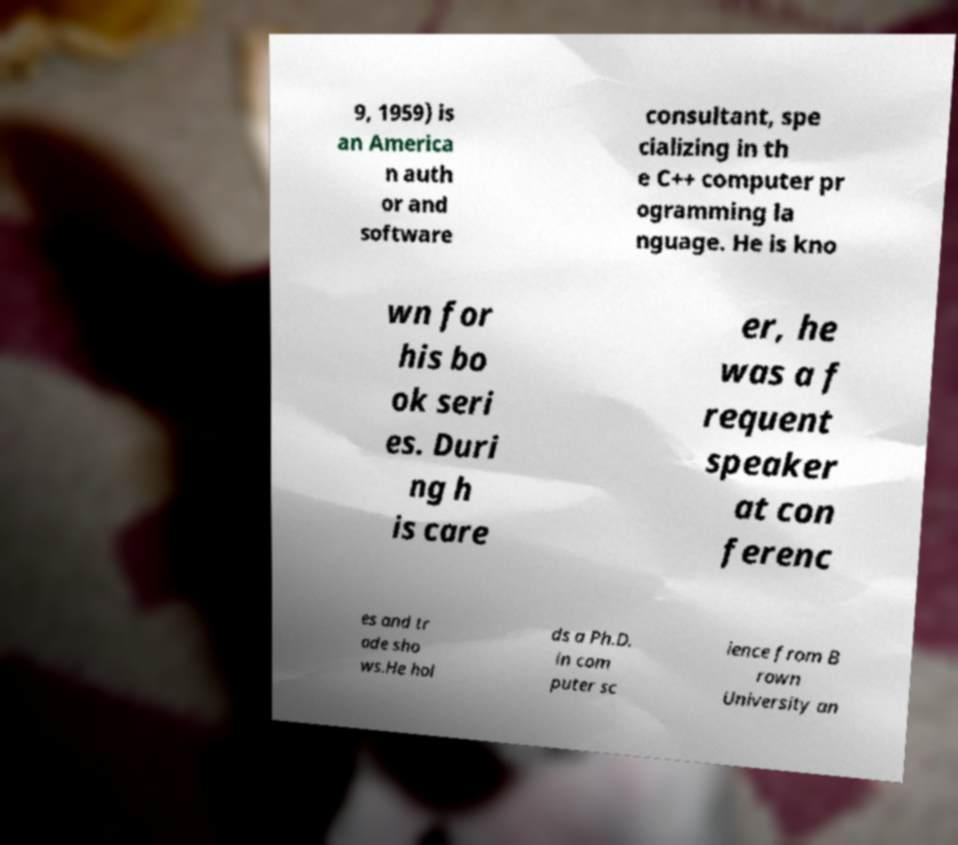For documentation purposes, I need the text within this image transcribed. Could you provide that? 9, 1959) is an America n auth or and software consultant, spe cializing in th e C++ computer pr ogramming la nguage. He is kno wn for his bo ok seri es. Duri ng h is care er, he was a f requent speaker at con ferenc es and tr ade sho ws.He hol ds a Ph.D. in com puter sc ience from B rown University an 